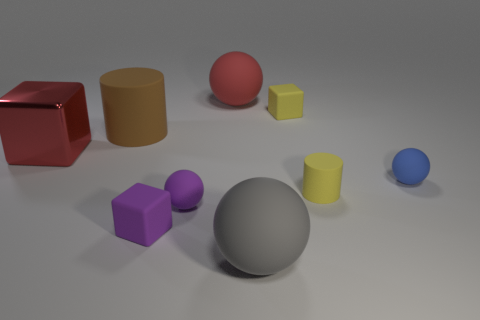Subtract all blue balls. How many balls are left? 3 Add 1 red shiny objects. How many objects exist? 10 Subtract all brown cylinders. How many cylinders are left? 1 Subtract 3 blocks. How many blocks are left? 0 Subtract all small green objects. Subtract all large red matte things. How many objects are left? 8 Add 2 big brown rubber cylinders. How many big brown rubber cylinders are left? 3 Add 6 tiny gray rubber cylinders. How many tiny gray rubber cylinders exist? 6 Subtract 0 green blocks. How many objects are left? 9 Subtract all spheres. How many objects are left? 5 Subtract all green cubes. Subtract all purple spheres. How many cubes are left? 3 